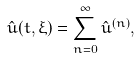<formula> <loc_0><loc_0><loc_500><loc_500>\hat { u } ( t , \xi ) = \sum _ { n = 0 } ^ { \infty } \hat { u } ^ { ( n ) } ,</formula> 